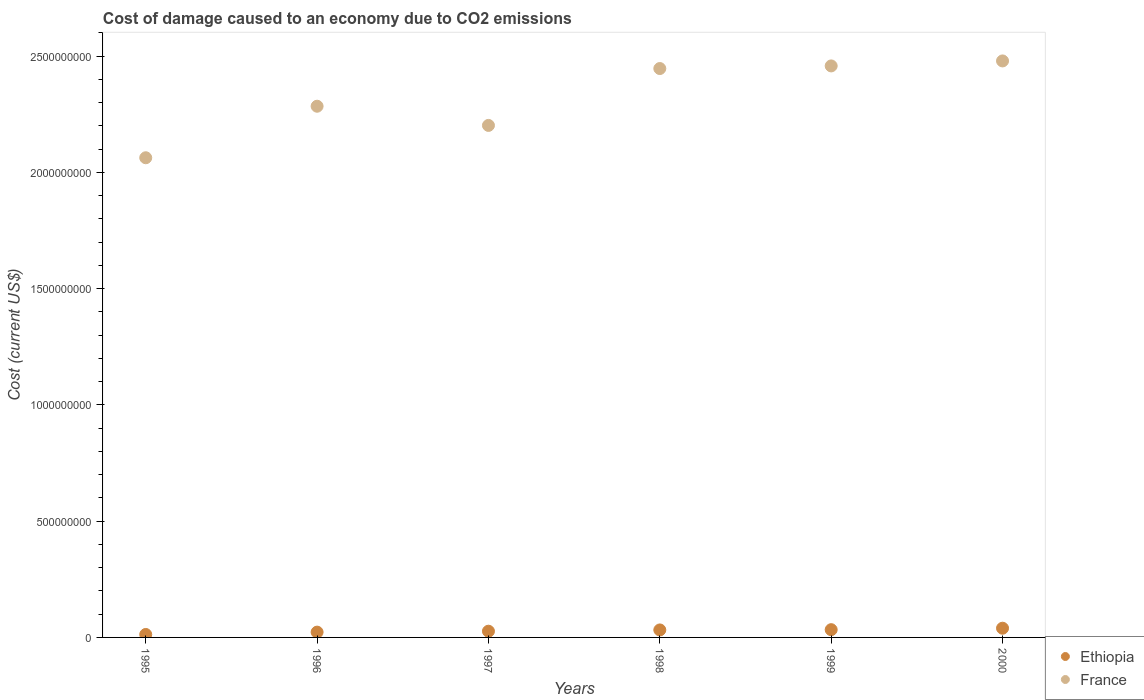What is the cost of damage caused due to CO2 emissisons in Ethiopia in 1997?
Your response must be concise. 2.68e+07. Across all years, what is the maximum cost of damage caused due to CO2 emissisons in France?
Provide a short and direct response. 2.48e+09. Across all years, what is the minimum cost of damage caused due to CO2 emissisons in France?
Offer a terse response. 2.06e+09. In which year was the cost of damage caused due to CO2 emissisons in France minimum?
Keep it short and to the point. 1995. What is the total cost of damage caused due to CO2 emissisons in France in the graph?
Offer a very short reply. 1.39e+1. What is the difference between the cost of damage caused due to CO2 emissisons in Ethiopia in 1995 and that in 1998?
Your answer should be very brief. -1.95e+07. What is the difference between the cost of damage caused due to CO2 emissisons in Ethiopia in 1998 and the cost of damage caused due to CO2 emissisons in France in 2000?
Keep it short and to the point. -2.45e+09. What is the average cost of damage caused due to CO2 emissisons in Ethiopia per year?
Provide a short and direct response. 2.79e+07. In the year 1997, what is the difference between the cost of damage caused due to CO2 emissisons in Ethiopia and cost of damage caused due to CO2 emissisons in France?
Give a very brief answer. -2.18e+09. What is the ratio of the cost of damage caused due to CO2 emissisons in France in 1995 to that in 1996?
Your answer should be very brief. 0.9. Is the difference between the cost of damage caused due to CO2 emissisons in Ethiopia in 1995 and 1999 greater than the difference between the cost of damage caused due to CO2 emissisons in France in 1995 and 1999?
Your answer should be very brief. Yes. What is the difference between the highest and the second highest cost of damage caused due to CO2 emissisons in France?
Your response must be concise. 2.15e+07. What is the difference between the highest and the lowest cost of damage caused due to CO2 emissisons in Ethiopia?
Provide a succinct answer. 2.70e+07. Is the cost of damage caused due to CO2 emissisons in Ethiopia strictly less than the cost of damage caused due to CO2 emissisons in France over the years?
Offer a very short reply. Yes. How many dotlines are there?
Provide a short and direct response. 2. What is the title of the graph?
Offer a terse response. Cost of damage caused to an economy due to CO2 emissions. What is the label or title of the Y-axis?
Offer a terse response. Cost (current US$). What is the Cost (current US$) of Ethiopia in 1995?
Keep it short and to the point. 1.27e+07. What is the Cost (current US$) in France in 1995?
Provide a short and direct response. 2.06e+09. What is the Cost (current US$) in Ethiopia in 1996?
Your answer should be compact. 2.28e+07. What is the Cost (current US$) in France in 1996?
Provide a succinct answer. 2.28e+09. What is the Cost (current US$) of Ethiopia in 1997?
Your answer should be compact. 2.68e+07. What is the Cost (current US$) in France in 1997?
Your answer should be compact. 2.20e+09. What is the Cost (current US$) of Ethiopia in 1998?
Offer a very short reply. 3.22e+07. What is the Cost (current US$) of France in 1998?
Your answer should be very brief. 2.45e+09. What is the Cost (current US$) in Ethiopia in 1999?
Keep it short and to the point. 3.33e+07. What is the Cost (current US$) of France in 1999?
Provide a succinct answer. 2.46e+09. What is the Cost (current US$) in Ethiopia in 2000?
Keep it short and to the point. 3.96e+07. What is the Cost (current US$) in France in 2000?
Ensure brevity in your answer.  2.48e+09. Across all years, what is the maximum Cost (current US$) in Ethiopia?
Provide a succinct answer. 3.96e+07. Across all years, what is the maximum Cost (current US$) of France?
Give a very brief answer. 2.48e+09. Across all years, what is the minimum Cost (current US$) in Ethiopia?
Your answer should be very brief. 1.27e+07. Across all years, what is the minimum Cost (current US$) of France?
Provide a succinct answer. 2.06e+09. What is the total Cost (current US$) of Ethiopia in the graph?
Offer a terse response. 1.67e+08. What is the total Cost (current US$) in France in the graph?
Make the answer very short. 1.39e+1. What is the difference between the Cost (current US$) in Ethiopia in 1995 and that in 1996?
Offer a very short reply. -1.01e+07. What is the difference between the Cost (current US$) of France in 1995 and that in 1996?
Provide a short and direct response. -2.22e+08. What is the difference between the Cost (current US$) in Ethiopia in 1995 and that in 1997?
Offer a very short reply. -1.41e+07. What is the difference between the Cost (current US$) in France in 1995 and that in 1997?
Your answer should be very brief. -1.39e+08. What is the difference between the Cost (current US$) of Ethiopia in 1995 and that in 1998?
Provide a short and direct response. -1.95e+07. What is the difference between the Cost (current US$) in France in 1995 and that in 1998?
Your response must be concise. -3.84e+08. What is the difference between the Cost (current US$) of Ethiopia in 1995 and that in 1999?
Your response must be concise. -2.07e+07. What is the difference between the Cost (current US$) of France in 1995 and that in 1999?
Provide a short and direct response. -3.95e+08. What is the difference between the Cost (current US$) of Ethiopia in 1995 and that in 2000?
Offer a terse response. -2.70e+07. What is the difference between the Cost (current US$) of France in 1995 and that in 2000?
Provide a succinct answer. -4.16e+08. What is the difference between the Cost (current US$) in Ethiopia in 1996 and that in 1997?
Your answer should be very brief. -3.97e+06. What is the difference between the Cost (current US$) in France in 1996 and that in 1997?
Your answer should be compact. 8.25e+07. What is the difference between the Cost (current US$) in Ethiopia in 1996 and that in 1998?
Offer a very short reply. -9.40e+06. What is the difference between the Cost (current US$) of France in 1996 and that in 1998?
Make the answer very short. -1.62e+08. What is the difference between the Cost (current US$) of Ethiopia in 1996 and that in 1999?
Provide a succinct answer. -1.05e+07. What is the difference between the Cost (current US$) of France in 1996 and that in 1999?
Give a very brief answer. -1.73e+08. What is the difference between the Cost (current US$) of Ethiopia in 1996 and that in 2000?
Give a very brief answer. -1.68e+07. What is the difference between the Cost (current US$) in France in 1996 and that in 2000?
Your answer should be compact. -1.95e+08. What is the difference between the Cost (current US$) of Ethiopia in 1997 and that in 1998?
Make the answer very short. -5.43e+06. What is the difference between the Cost (current US$) of France in 1997 and that in 1998?
Offer a terse response. -2.45e+08. What is the difference between the Cost (current US$) in Ethiopia in 1997 and that in 1999?
Give a very brief answer. -6.57e+06. What is the difference between the Cost (current US$) in France in 1997 and that in 1999?
Keep it short and to the point. -2.56e+08. What is the difference between the Cost (current US$) in Ethiopia in 1997 and that in 2000?
Make the answer very short. -1.29e+07. What is the difference between the Cost (current US$) in France in 1997 and that in 2000?
Your answer should be compact. -2.77e+08. What is the difference between the Cost (current US$) in Ethiopia in 1998 and that in 1999?
Give a very brief answer. -1.14e+06. What is the difference between the Cost (current US$) of France in 1998 and that in 1999?
Your answer should be very brief. -1.13e+07. What is the difference between the Cost (current US$) in Ethiopia in 1998 and that in 2000?
Offer a terse response. -7.45e+06. What is the difference between the Cost (current US$) of France in 1998 and that in 2000?
Make the answer very short. -3.27e+07. What is the difference between the Cost (current US$) of Ethiopia in 1999 and that in 2000?
Provide a short and direct response. -6.30e+06. What is the difference between the Cost (current US$) of France in 1999 and that in 2000?
Make the answer very short. -2.15e+07. What is the difference between the Cost (current US$) in Ethiopia in 1995 and the Cost (current US$) in France in 1996?
Your answer should be very brief. -2.27e+09. What is the difference between the Cost (current US$) in Ethiopia in 1995 and the Cost (current US$) in France in 1997?
Give a very brief answer. -2.19e+09. What is the difference between the Cost (current US$) in Ethiopia in 1995 and the Cost (current US$) in France in 1998?
Make the answer very short. -2.43e+09. What is the difference between the Cost (current US$) in Ethiopia in 1995 and the Cost (current US$) in France in 1999?
Your answer should be very brief. -2.45e+09. What is the difference between the Cost (current US$) in Ethiopia in 1995 and the Cost (current US$) in France in 2000?
Ensure brevity in your answer.  -2.47e+09. What is the difference between the Cost (current US$) of Ethiopia in 1996 and the Cost (current US$) of France in 1997?
Offer a terse response. -2.18e+09. What is the difference between the Cost (current US$) in Ethiopia in 1996 and the Cost (current US$) in France in 1998?
Provide a succinct answer. -2.42e+09. What is the difference between the Cost (current US$) in Ethiopia in 1996 and the Cost (current US$) in France in 1999?
Your response must be concise. -2.44e+09. What is the difference between the Cost (current US$) in Ethiopia in 1996 and the Cost (current US$) in France in 2000?
Your answer should be very brief. -2.46e+09. What is the difference between the Cost (current US$) in Ethiopia in 1997 and the Cost (current US$) in France in 1998?
Provide a succinct answer. -2.42e+09. What is the difference between the Cost (current US$) in Ethiopia in 1997 and the Cost (current US$) in France in 1999?
Provide a succinct answer. -2.43e+09. What is the difference between the Cost (current US$) in Ethiopia in 1997 and the Cost (current US$) in France in 2000?
Provide a succinct answer. -2.45e+09. What is the difference between the Cost (current US$) in Ethiopia in 1998 and the Cost (current US$) in France in 1999?
Give a very brief answer. -2.43e+09. What is the difference between the Cost (current US$) in Ethiopia in 1998 and the Cost (current US$) in France in 2000?
Provide a short and direct response. -2.45e+09. What is the difference between the Cost (current US$) in Ethiopia in 1999 and the Cost (current US$) in France in 2000?
Offer a terse response. -2.45e+09. What is the average Cost (current US$) in Ethiopia per year?
Keep it short and to the point. 2.79e+07. What is the average Cost (current US$) in France per year?
Give a very brief answer. 2.32e+09. In the year 1995, what is the difference between the Cost (current US$) of Ethiopia and Cost (current US$) of France?
Keep it short and to the point. -2.05e+09. In the year 1996, what is the difference between the Cost (current US$) in Ethiopia and Cost (current US$) in France?
Ensure brevity in your answer.  -2.26e+09. In the year 1997, what is the difference between the Cost (current US$) in Ethiopia and Cost (current US$) in France?
Make the answer very short. -2.18e+09. In the year 1998, what is the difference between the Cost (current US$) of Ethiopia and Cost (current US$) of France?
Your answer should be compact. -2.41e+09. In the year 1999, what is the difference between the Cost (current US$) in Ethiopia and Cost (current US$) in France?
Provide a short and direct response. -2.42e+09. In the year 2000, what is the difference between the Cost (current US$) of Ethiopia and Cost (current US$) of France?
Keep it short and to the point. -2.44e+09. What is the ratio of the Cost (current US$) in Ethiopia in 1995 to that in 1996?
Your answer should be very brief. 0.56. What is the ratio of the Cost (current US$) of France in 1995 to that in 1996?
Your answer should be compact. 0.9. What is the ratio of the Cost (current US$) of Ethiopia in 1995 to that in 1997?
Offer a very short reply. 0.47. What is the ratio of the Cost (current US$) of France in 1995 to that in 1997?
Provide a succinct answer. 0.94. What is the ratio of the Cost (current US$) of Ethiopia in 1995 to that in 1998?
Keep it short and to the point. 0.39. What is the ratio of the Cost (current US$) of France in 1995 to that in 1998?
Offer a very short reply. 0.84. What is the ratio of the Cost (current US$) of Ethiopia in 1995 to that in 1999?
Ensure brevity in your answer.  0.38. What is the ratio of the Cost (current US$) in France in 1995 to that in 1999?
Give a very brief answer. 0.84. What is the ratio of the Cost (current US$) in Ethiopia in 1995 to that in 2000?
Offer a terse response. 0.32. What is the ratio of the Cost (current US$) in France in 1995 to that in 2000?
Your answer should be very brief. 0.83. What is the ratio of the Cost (current US$) in Ethiopia in 1996 to that in 1997?
Your answer should be compact. 0.85. What is the ratio of the Cost (current US$) in France in 1996 to that in 1997?
Your response must be concise. 1.04. What is the ratio of the Cost (current US$) of Ethiopia in 1996 to that in 1998?
Your answer should be compact. 0.71. What is the ratio of the Cost (current US$) of France in 1996 to that in 1998?
Provide a succinct answer. 0.93. What is the ratio of the Cost (current US$) of Ethiopia in 1996 to that in 1999?
Your answer should be compact. 0.68. What is the ratio of the Cost (current US$) of France in 1996 to that in 1999?
Offer a terse response. 0.93. What is the ratio of the Cost (current US$) in Ethiopia in 1996 to that in 2000?
Offer a terse response. 0.58. What is the ratio of the Cost (current US$) of France in 1996 to that in 2000?
Offer a terse response. 0.92. What is the ratio of the Cost (current US$) of Ethiopia in 1997 to that in 1998?
Your answer should be compact. 0.83. What is the ratio of the Cost (current US$) of France in 1997 to that in 1998?
Keep it short and to the point. 0.9. What is the ratio of the Cost (current US$) in Ethiopia in 1997 to that in 1999?
Provide a succinct answer. 0.8. What is the ratio of the Cost (current US$) of France in 1997 to that in 1999?
Your answer should be compact. 0.9. What is the ratio of the Cost (current US$) of Ethiopia in 1997 to that in 2000?
Your answer should be compact. 0.68. What is the ratio of the Cost (current US$) of France in 1997 to that in 2000?
Provide a short and direct response. 0.89. What is the ratio of the Cost (current US$) in Ethiopia in 1998 to that in 1999?
Your response must be concise. 0.97. What is the ratio of the Cost (current US$) in Ethiopia in 1998 to that in 2000?
Provide a short and direct response. 0.81. What is the ratio of the Cost (current US$) of France in 1998 to that in 2000?
Provide a short and direct response. 0.99. What is the ratio of the Cost (current US$) of Ethiopia in 1999 to that in 2000?
Offer a very short reply. 0.84. What is the ratio of the Cost (current US$) in France in 1999 to that in 2000?
Keep it short and to the point. 0.99. What is the difference between the highest and the second highest Cost (current US$) of Ethiopia?
Provide a short and direct response. 6.30e+06. What is the difference between the highest and the second highest Cost (current US$) of France?
Give a very brief answer. 2.15e+07. What is the difference between the highest and the lowest Cost (current US$) of Ethiopia?
Provide a short and direct response. 2.70e+07. What is the difference between the highest and the lowest Cost (current US$) in France?
Offer a terse response. 4.16e+08. 